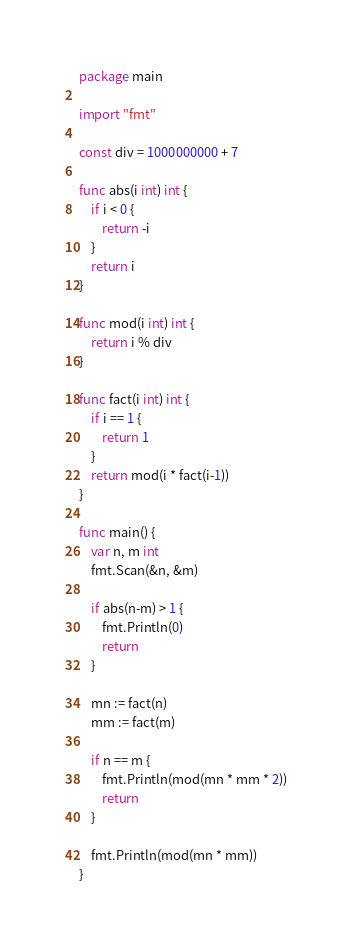<code> <loc_0><loc_0><loc_500><loc_500><_Go_>package main

import "fmt"

const div = 1000000000 + 7

func abs(i int) int {
	if i < 0 {
		return -i
	}
	return i
}

func mod(i int) int {
	return i % div
}

func fact(i int) int {
	if i == 1 {
		return 1
	}
	return mod(i * fact(i-1))
}

func main() {
	var n, m int
	fmt.Scan(&n, &m)

	if abs(n-m) > 1 {
		fmt.Println(0)
		return
	}

	mn := fact(n)
	mm := fact(m)

	if n == m {
		fmt.Println(mod(mn * mm * 2))
		return
	}

	fmt.Println(mod(mn * mm))
}</code> 